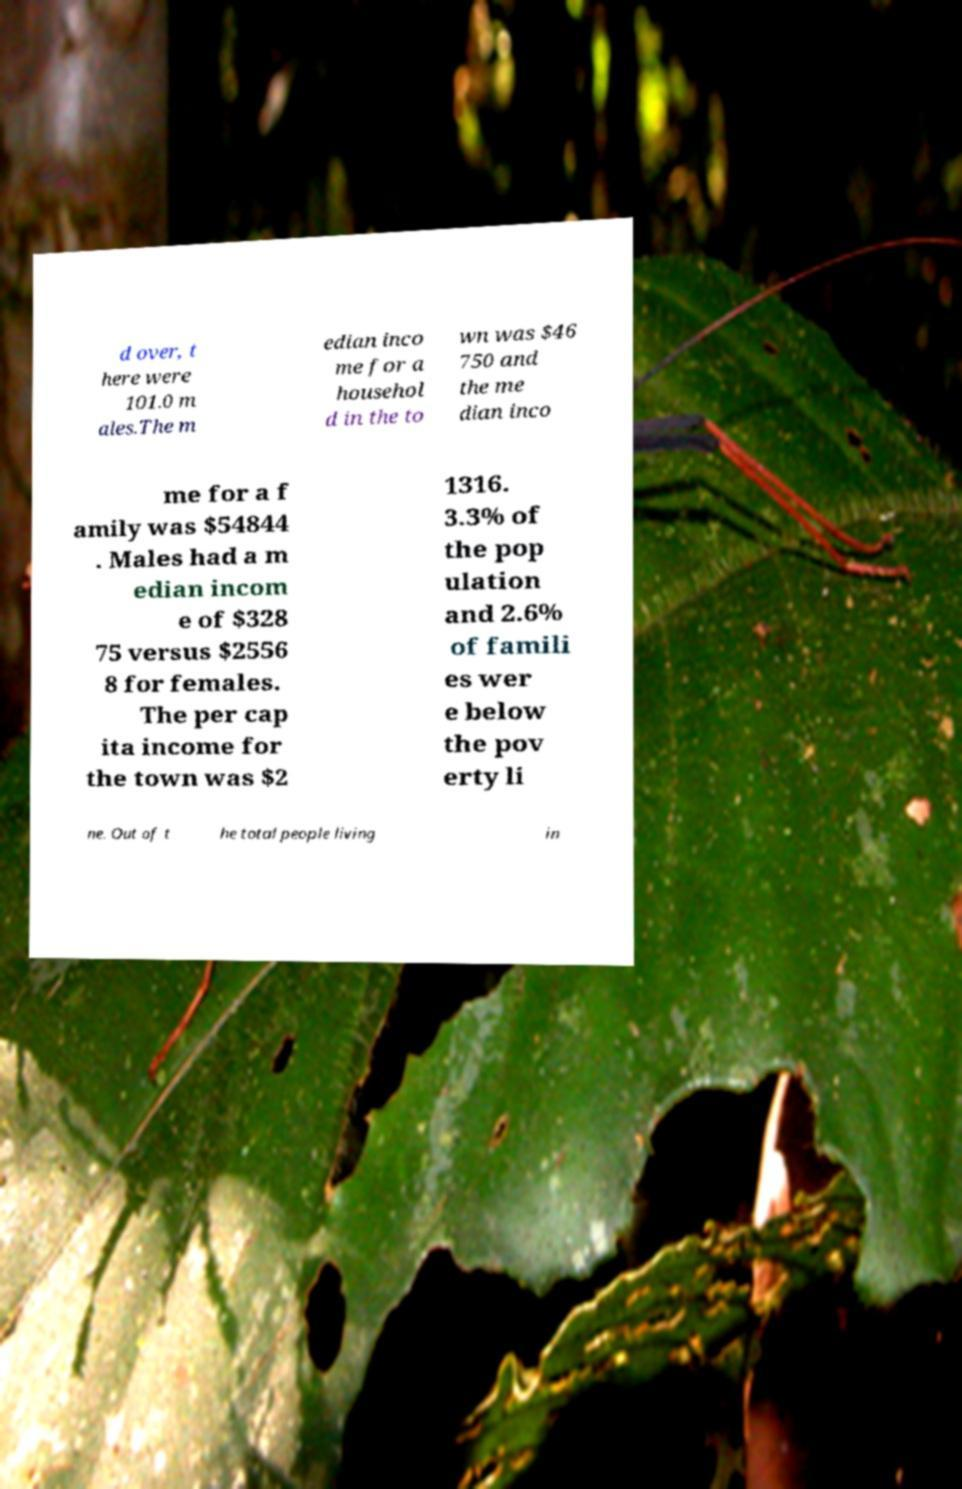Can you read and provide the text displayed in the image?This photo seems to have some interesting text. Can you extract and type it out for me? d over, t here were 101.0 m ales.The m edian inco me for a househol d in the to wn was $46 750 and the me dian inco me for a f amily was $54844 . Males had a m edian incom e of $328 75 versus $2556 8 for females. The per cap ita income for the town was $2 1316. 3.3% of the pop ulation and 2.6% of famili es wer e below the pov erty li ne. Out of t he total people living in 